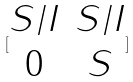<formula> <loc_0><loc_0><loc_500><loc_500>[ \begin{matrix} S / I & S / I \\ 0 & S \end{matrix} ]</formula> 